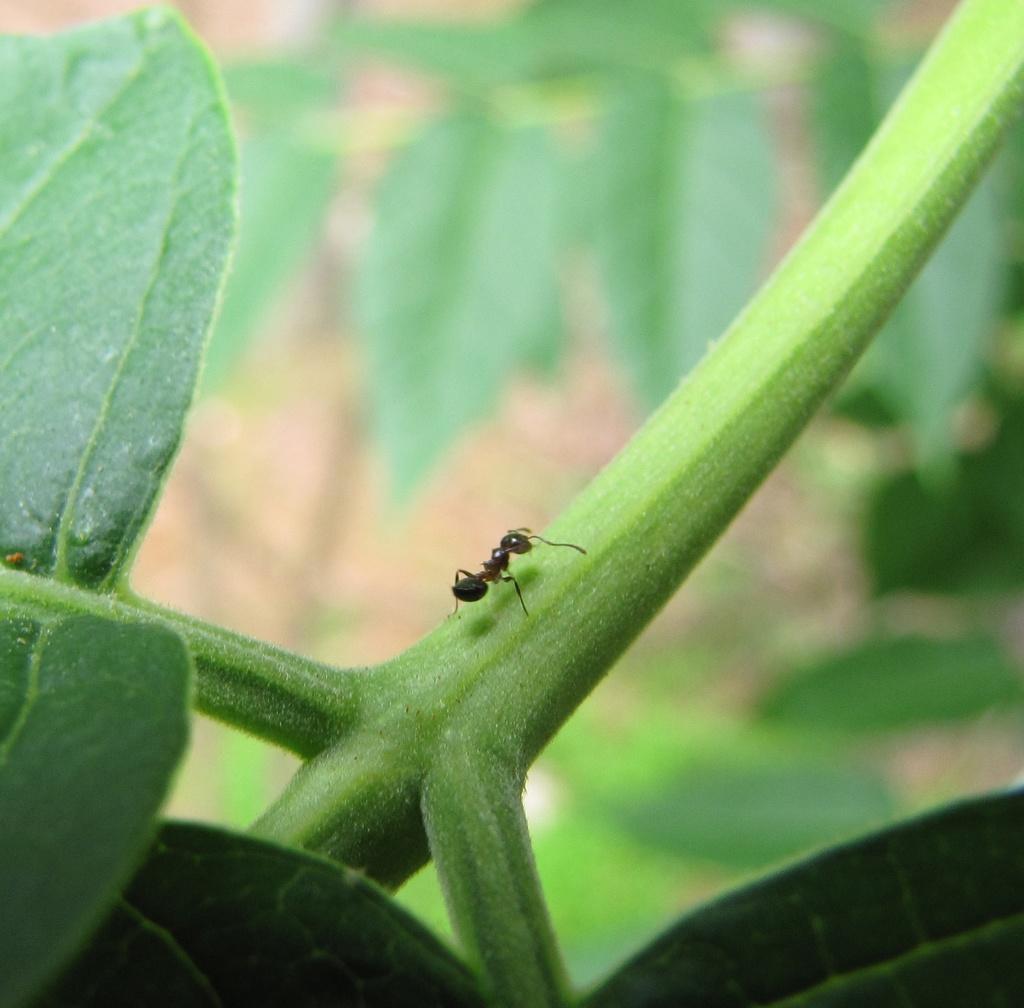In one or two sentences, can you explain what this image depicts? In the center of the image we can see ant on the plant. 